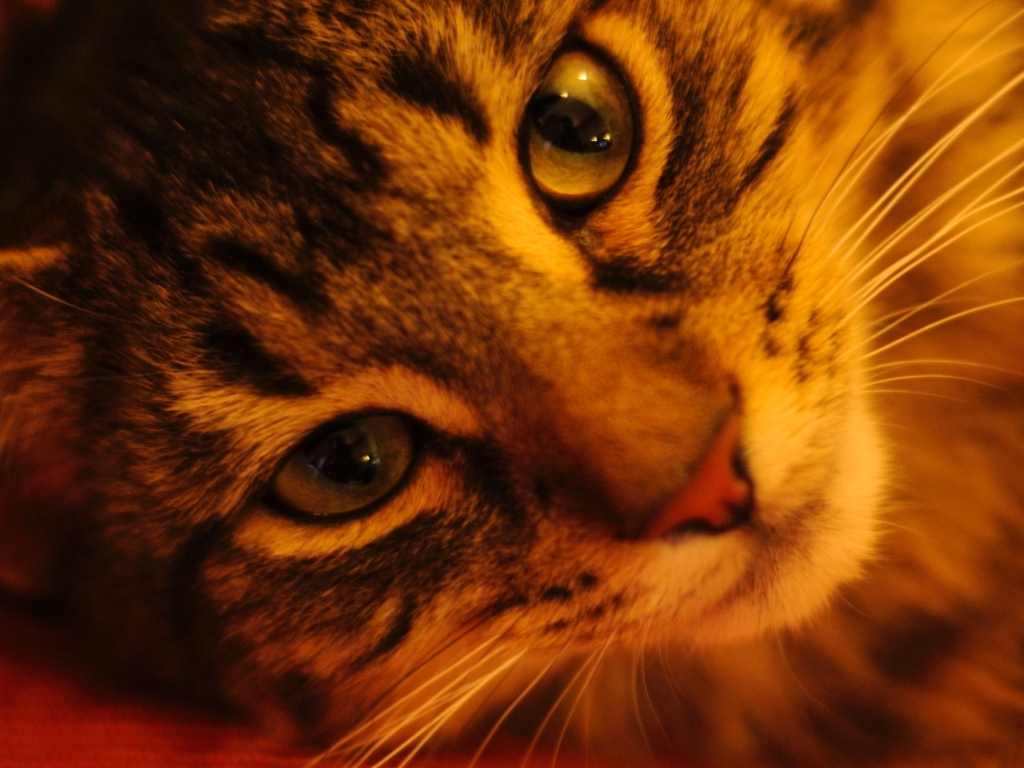What emotion does the cat seem to be expressing? The cat's slightly tilted head and the intensity in its eyes convey a sense of curiosity and engagement, commonly observed in cats when they're focused on something that has caught their interest. 